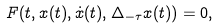<formula> <loc_0><loc_0><loc_500><loc_500>F ( t , x ( t ) , \dot { x } ( t ) , \Delta _ { - \tau } x ( t ) ) = 0 ,</formula> 